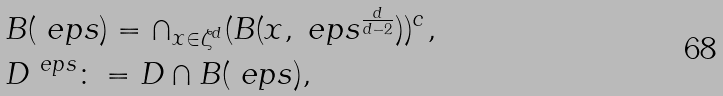<formula> <loc_0><loc_0><loc_500><loc_500>& B ( \ e p s ) = \cap _ { x \in \zeta ^ { d } } ( B ( x , \ e p s ^ { \frac { d } { d - 2 } } ) ) ^ { c } , \\ & D ^ { \ e p s } \colon = D \cap B ( \ e p s ) ,</formula> 